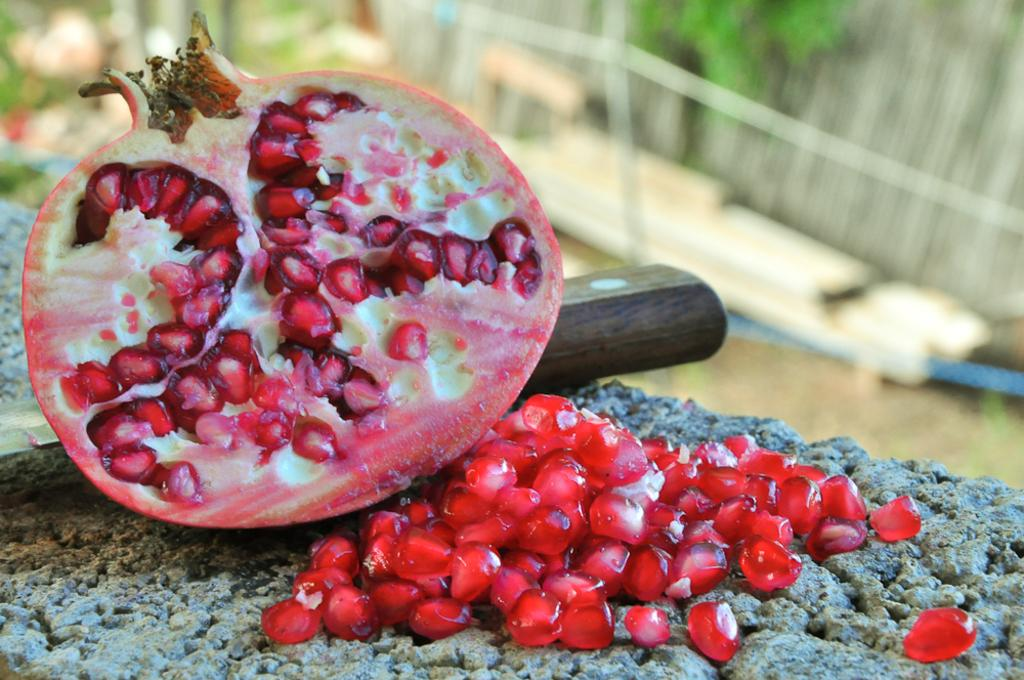What type of fruit is shown in the image? There is a half piece of pomegranate in the image. What tool is visible in the image? A knife is visible in the image. What is the result of cutting the pomegranate? Grains of pomegranate are present. Can you describe the background of the image? The background of the image is blurred. What type of plantation can be seen in the background of the image? There is no plantation visible in the image; the background is blurred. 